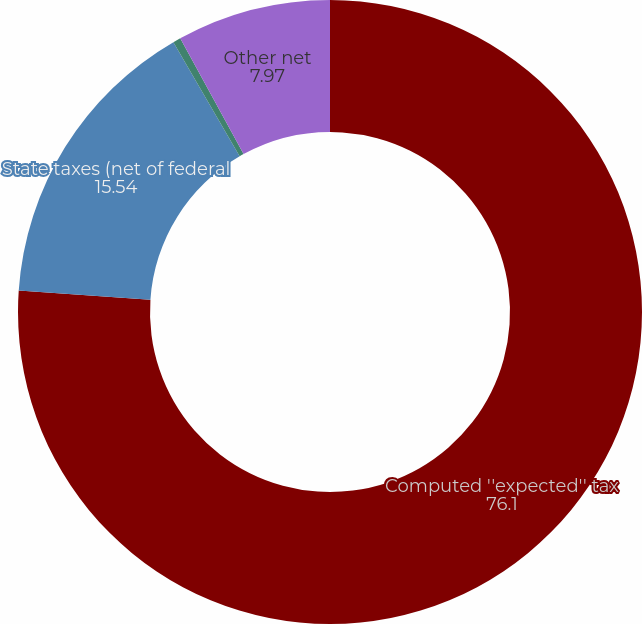Convert chart to OTSL. <chart><loc_0><loc_0><loc_500><loc_500><pie_chart><fcel>Computed ''expected'' tax<fcel>State taxes (net of federal<fcel>Foreign tax rate and tax law<fcel>Other net<nl><fcel>76.1%<fcel>15.54%<fcel>0.4%<fcel>7.97%<nl></chart> 